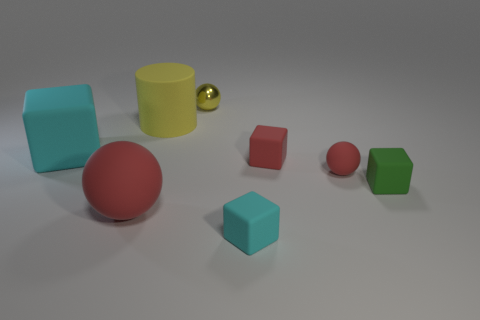Subtract all metallic balls. How many balls are left? 2 Subtract all brown balls. How many cyan blocks are left? 2 Add 1 small red matte blocks. How many objects exist? 9 Subtract all yellow spheres. How many spheres are left? 2 Subtract 1 cylinders. How many cylinders are left? 0 Add 8 cyan rubber things. How many cyan rubber things are left? 10 Add 1 metal things. How many metal things exist? 2 Subtract 0 cyan cylinders. How many objects are left? 8 Subtract all cylinders. How many objects are left? 7 Subtract all yellow blocks. Subtract all red spheres. How many blocks are left? 4 